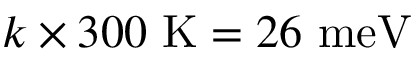Convert formula to latex. <formula><loc_0><loc_0><loc_500><loc_500>k \times 3 0 0 K = 2 6 m e V</formula> 